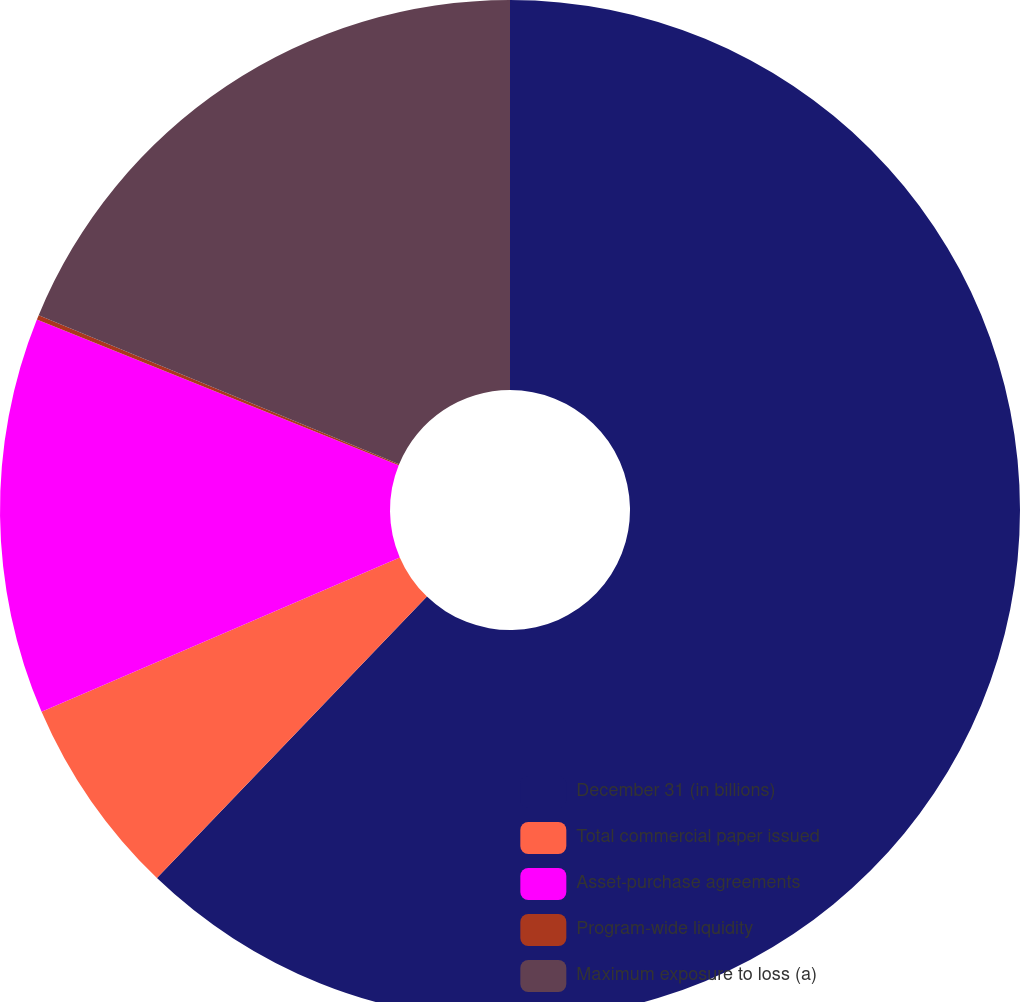Convert chart. <chart><loc_0><loc_0><loc_500><loc_500><pie_chart><fcel>December 31 (in billions)<fcel>Total commercial paper issued<fcel>Asset-purchase agreements<fcel>Program-wide liquidity<fcel>Maximum exposure to loss (a)<nl><fcel>62.17%<fcel>6.36%<fcel>12.56%<fcel>0.15%<fcel>18.76%<nl></chart> 